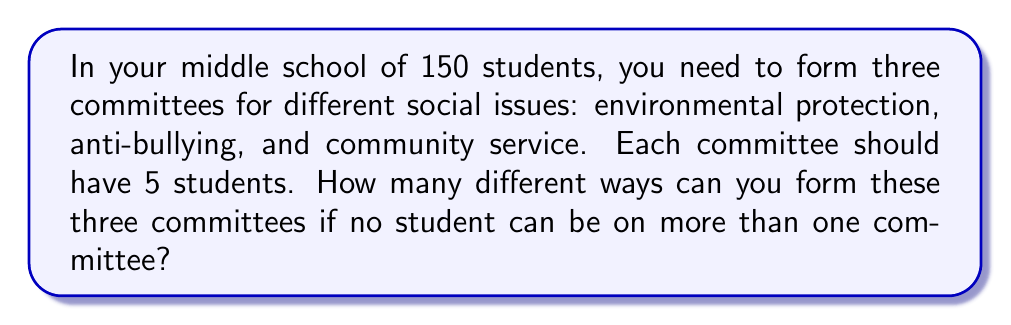Provide a solution to this math problem. Let's approach this step-by-step:

1) We need to choose 5 students for each of the three committees from 150 students.

2) For the first committee (let's say environmental protection):
   We need to choose 5 students from 150.
   This can be done in $\binom{150}{5}$ ways.

3) For the second committee (anti-bullying):
   After choosing 5 students for the first committee, we have 145 students left.
   We need to choose 5 from these 145.
   This can be done in $\binom{145}{5}$ ways.

4) For the third committee (community service):
   We now have 140 students left.
   We need to choose 5 from these 140.
   This can be done in $\binom{140}{5}$ ways.

5) By the multiplication principle, the total number of ways to form these three committees is:

   $$\binom{150}{5} \times \binom{145}{5} \times \binom{140}{5}$$

6) We can calculate this:
   $$\binom{150}{5} = 591,600,030$$
   $$\binom{145}{5} = 432,271,230$$
   $$\binom{140}{5} = 314,457,495$$

7) Multiplying these numbers:
   $$591,600,030 \times 432,271,230 \times 314,457,495 = 80,324,188,348,439,200,000,000$$

Therefore, there are 80,324,188,348,439,200,000,000 different ways to form these three committees.
Answer: 80,324,188,348,439,200,000,000 